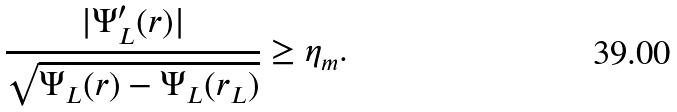<formula> <loc_0><loc_0><loc_500><loc_500>\frac { | \Psi ^ { \prime } _ { L } ( r ) | } { \sqrt { \Psi _ { L } ( r ) - \Psi _ { L } ( r _ { L } ) } } \geq \eta _ { m } .</formula> 